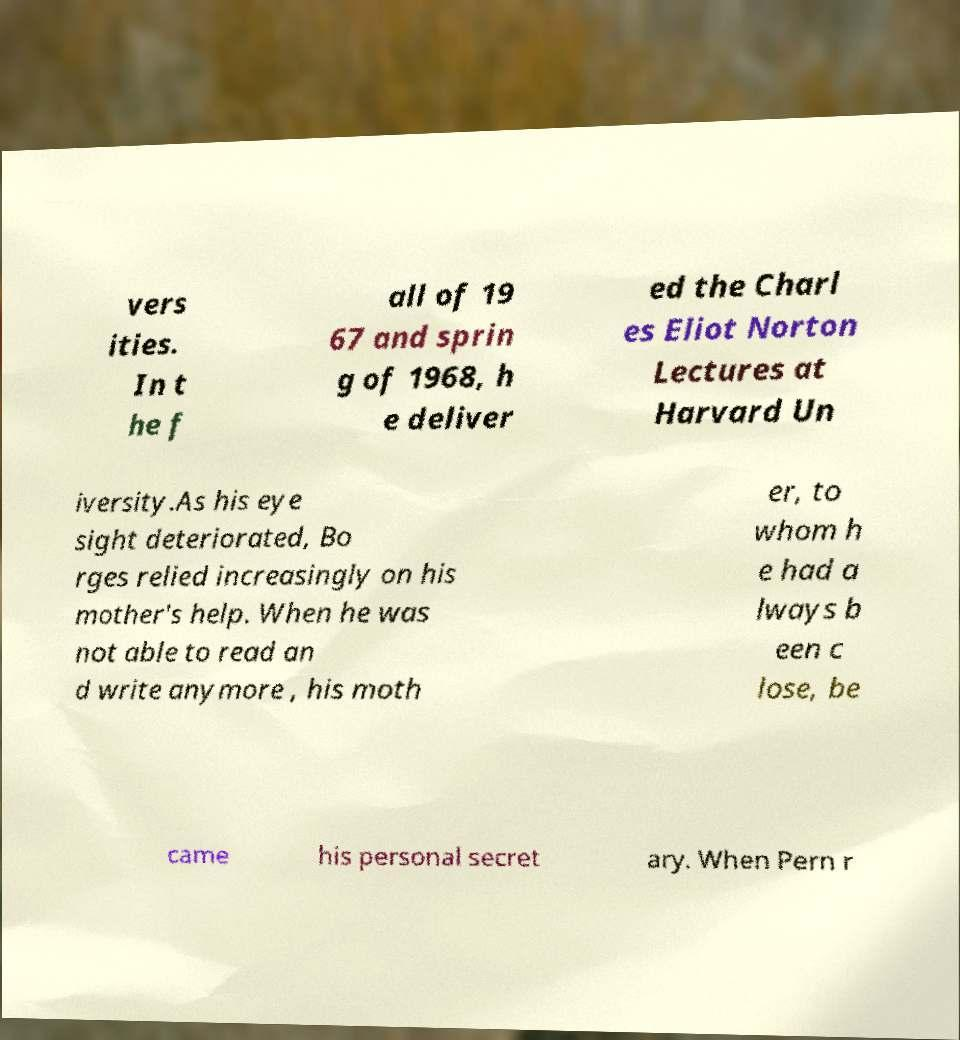Please identify and transcribe the text found in this image. vers ities. In t he f all of 19 67 and sprin g of 1968, h e deliver ed the Charl es Eliot Norton Lectures at Harvard Un iversity.As his eye sight deteriorated, Bo rges relied increasingly on his mother's help. When he was not able to read an d write anymore , his moth er, to whom h e had a lways b een c lose, be came his personal secret ary. When Pern r 